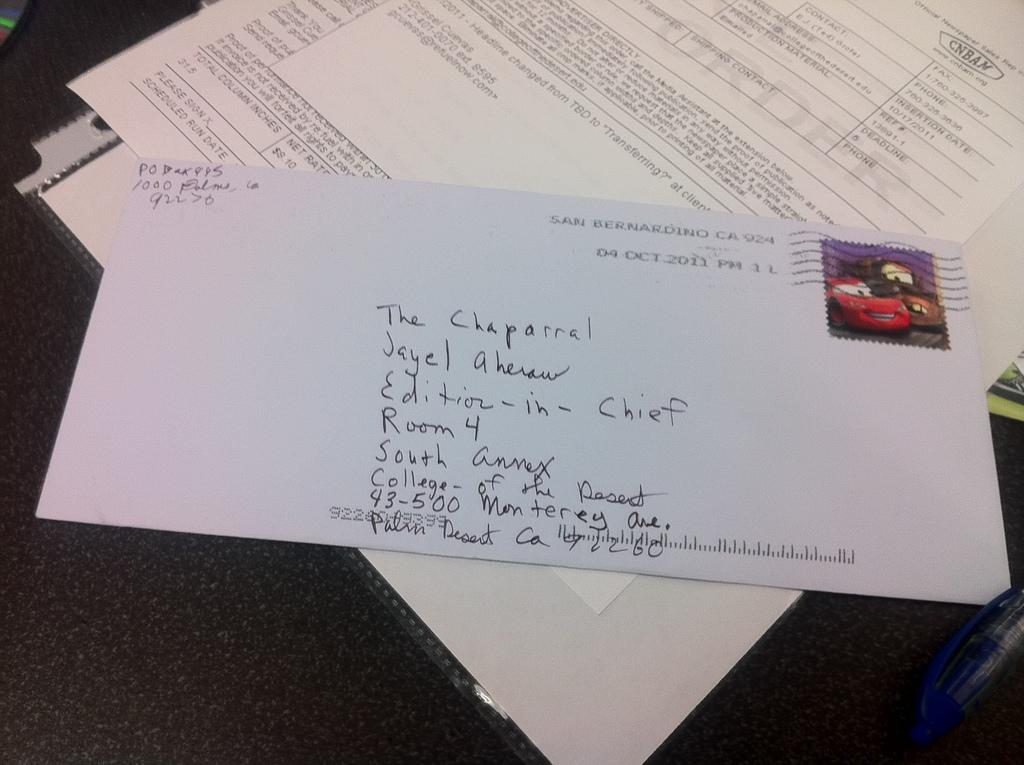Provide a one-sentence caption for the provided image. an envelope with hand written address for The Chaparral. 